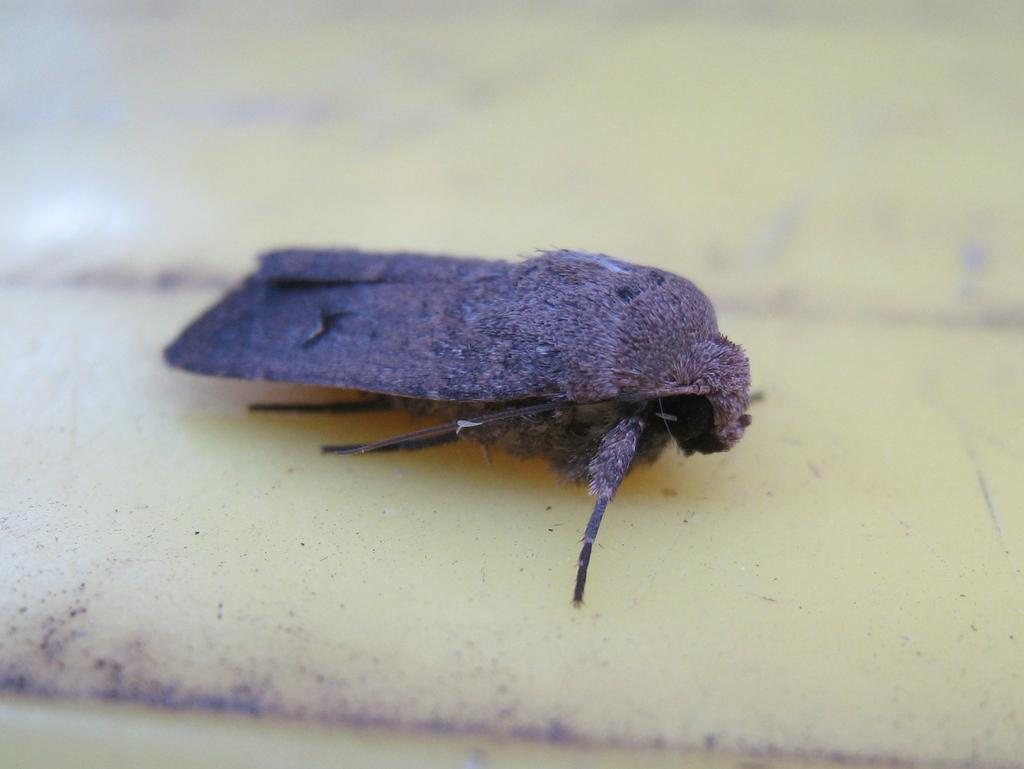What type of creature is present in the image? There is an insect in the image. Where is the insect located in the image? The insect is on the floor. How many pencils are present in the image? There is no mention of pencils in the provided facts, so we cannot determine the amount of pencils in the image. 